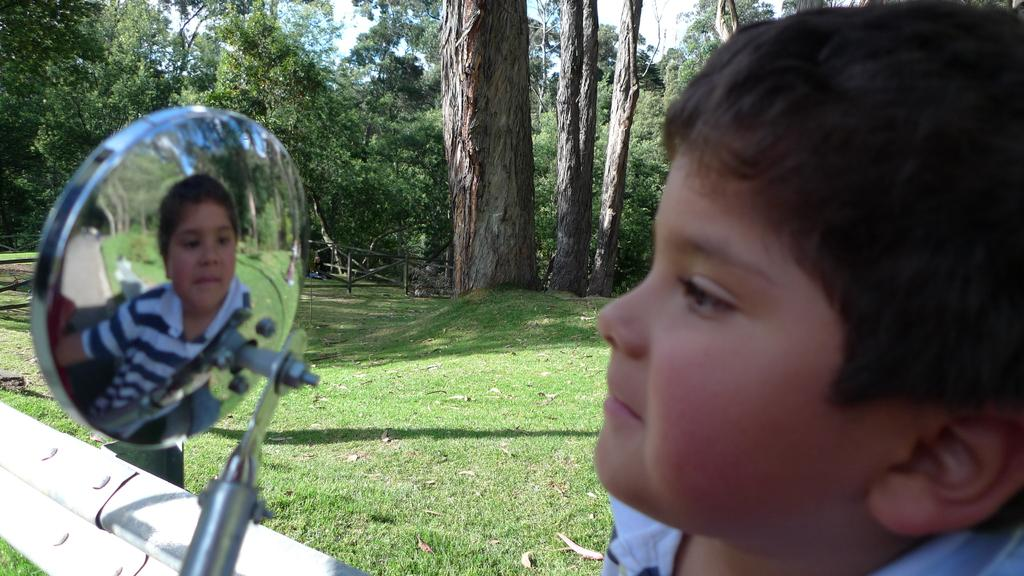What is the main subject of the image? There is a person's face in the image. What can be seen in the background of the image? Trees, fencing, and grass are visible in the background. What type of object is in the front of the image? There is a steel object in the front of the image. What type of roof can be seen in the image? There is no roof present in the image. Is there an actor performing in the image? The image only shows a person's face, and there is no indication of a performance or an actor. 